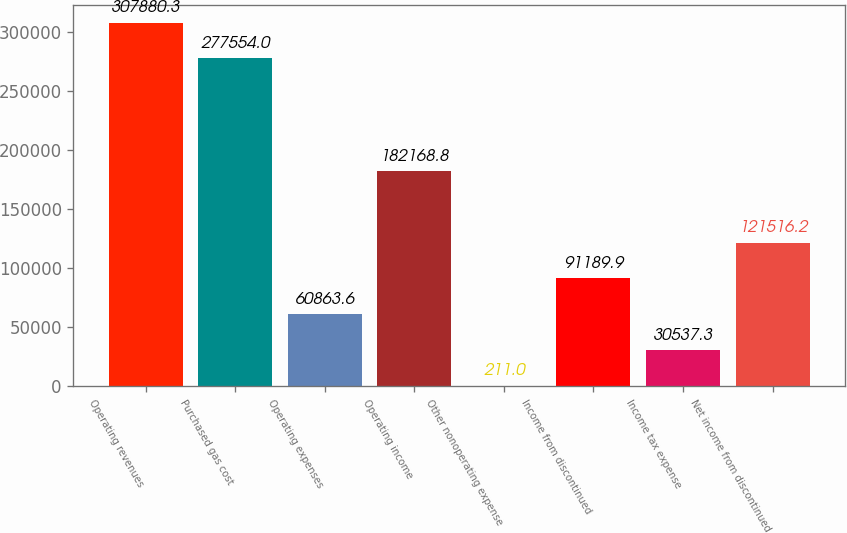Convert chart. <chart><loc_0><loc_0><loc_500><loc_500><bar_chart><fcel>Operating revenues<fcel>Purchased gas cost<fcel>Operating expenses<fcel>Operating income<fcel>Other nonoperating expense<fcel>Income from discontinued<fcel>Income tax expense<fcel>Net income from discontinued<nl><fcel>307880<fcel>277554<fcel>60863.6<fcel>182169<fcel>211<fcel>91189.9<fcel>30537.3<fcel>121516<nl></chart> 